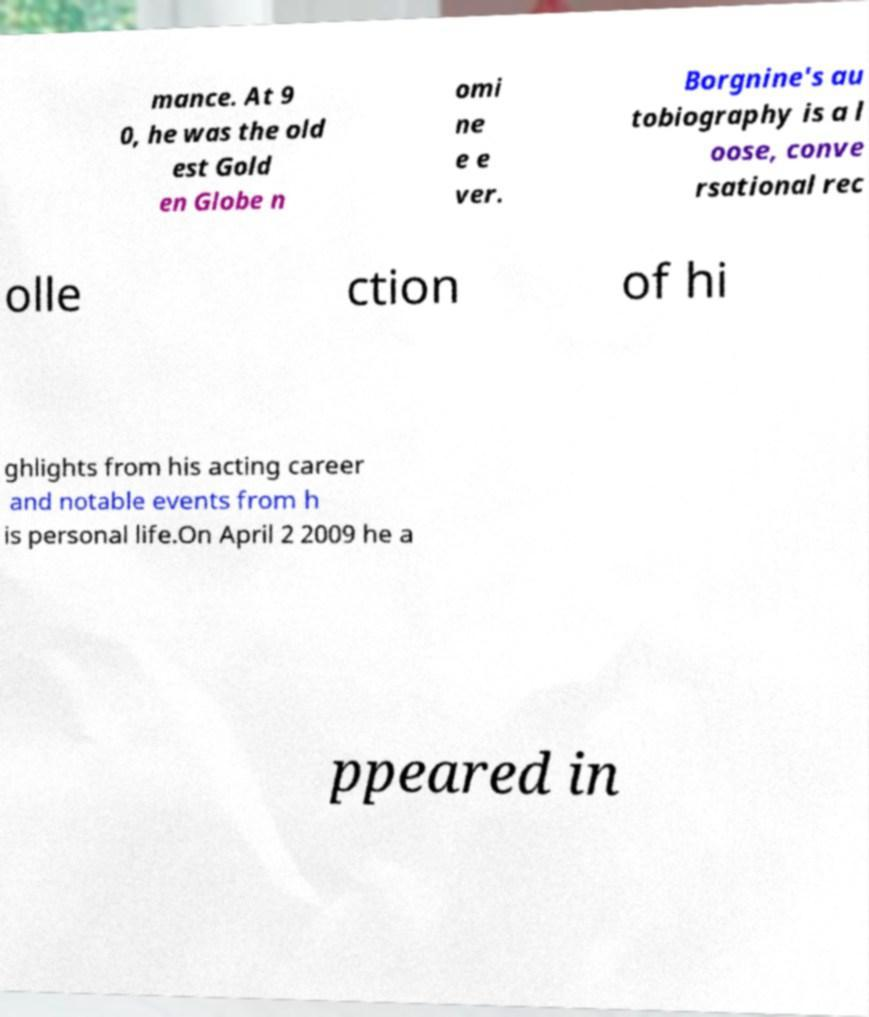Please read and relay the text visible in this image. What does it say? mance. At 9 0, he was the old est Gold en Globe n omi ne e e ver. Borgnine's au tobiography is a l oose, conve rsational rec olle ction of hi ghlights from his acting career and notable events from h is personal life.On April 2 2009 he a ppeared in 